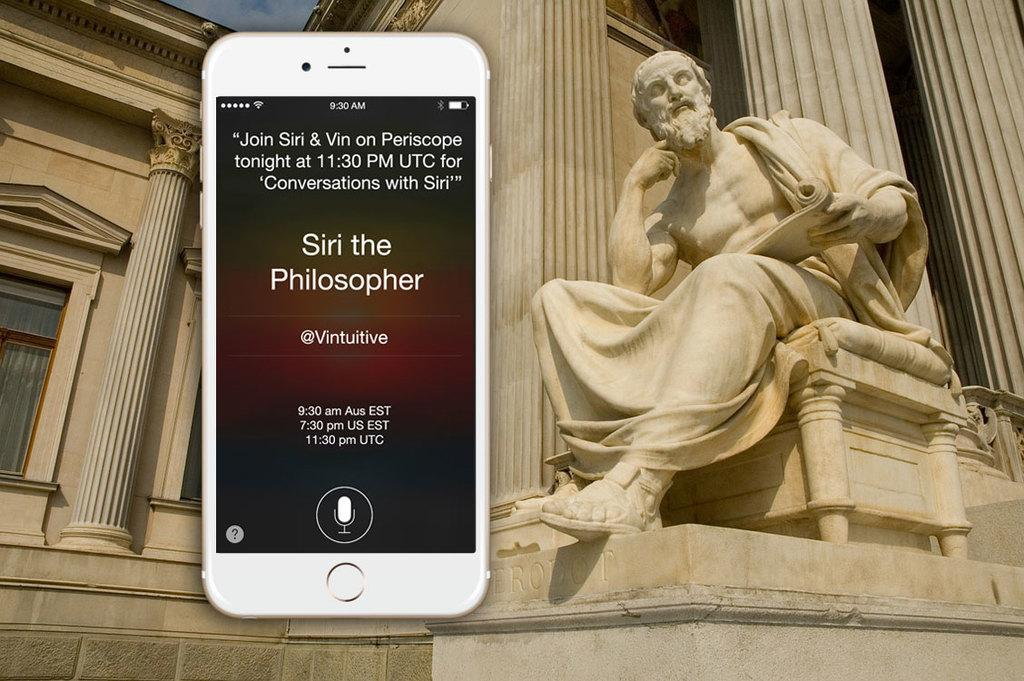What is the main subject of the sculpture in the image? The sculpture in the image is of a man. What is the color of the sculpture and the building in the image? Both the sculpture and the building in the image are white-colored. What object can be seen in the image that is commonly used for communication? There is a depiction of a phone in the image. What can be found in the image that conveys information through written words? There is text written in the image. Can you see any deer in the image? No, there are no deer present in the image. What type of magic is being performed by the man in the sculpture? There is no magic being performed by the man in the sculpture; it is a static sculpture. How many potatoes are visible in the image? There are no potatoes present in the image. 